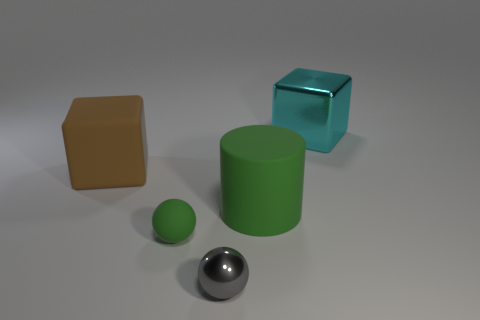The large rubber object to the right of the big block in front of the cyan object is what shape?
Your response must be concise. Cylinder. There is a gray thing that is the same material as the big cyan block; what shape is it?
Provide a short and direct response. Sphere. What is the size of the green object in front of the green object that is behind the small green sphere?
Provide a short and direct response. Small. What is the shape of the large green object?
Provide a short and direct response. Cylinder. What number of big objects are either purple rubber spheres or balls?
Your response must be concise. 0. What size is the other thing that is the same shape as the large brown object?
Keep it short and to the point. Large. What number of rubber objects are both behind the small green rubber thing and on the left side of the small gray metal sphere?
Offer a very short reply. 1. There is a big green rubber thing; is its shape the same as the tiny thing that is behind the tiny metal thing?
Your response must be concise. No. Are there more large green matte objects right of the gray metallic ball than big green cubes?
Your response must be concise. Yes. Is the number of small gray metallic things that are behind the metallic ball less than the number of big cyan metallic cylinders?
Give a very brief answer. No. 